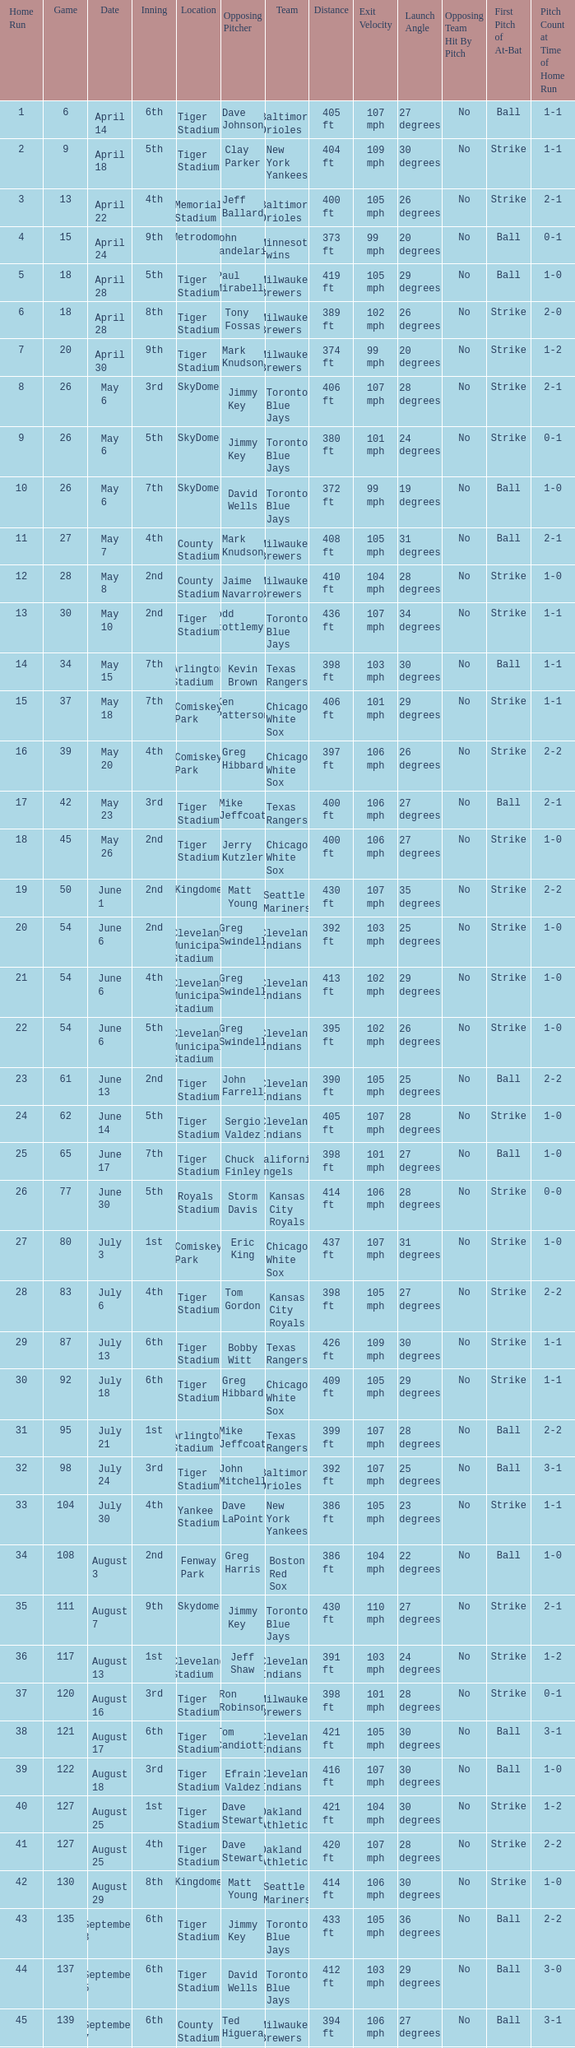On June 17 in Tiger stadium, what was the average home run? 25.0. 